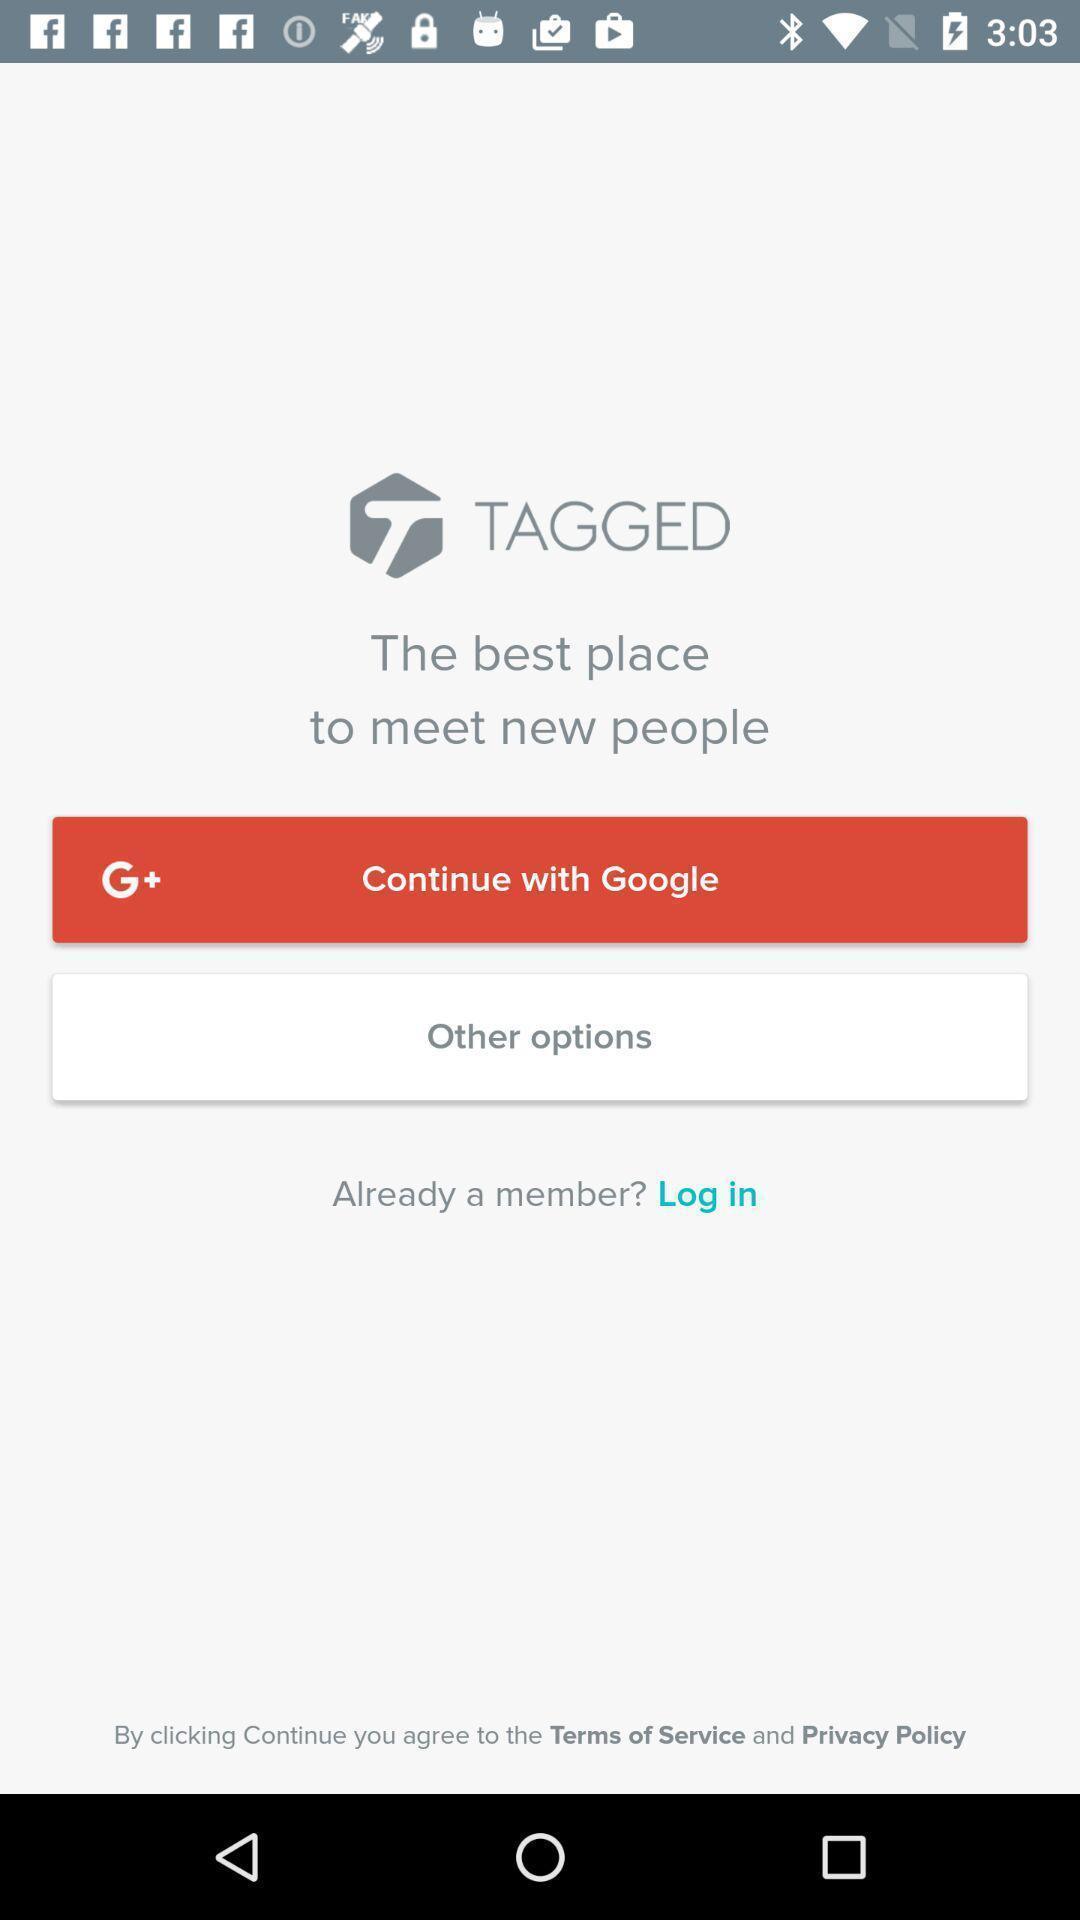Describe the visual elements of this screenshot. Login page with some options in gaming app. 